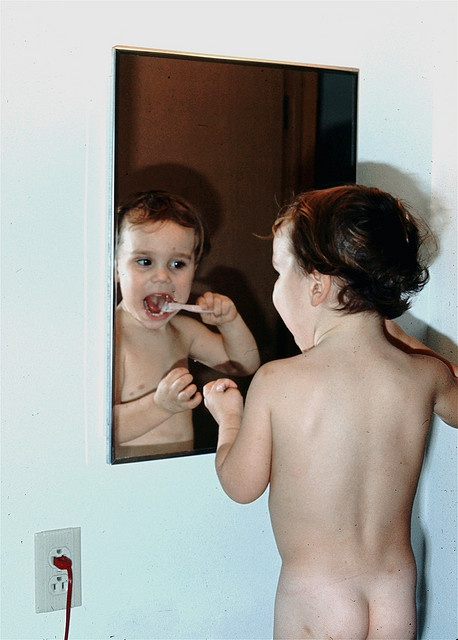Describe the objects in this image and their specific colors. I can see people in white, darkgray, tan, black, and gray tones, people in white, gray, tan, and black tones, and toothbrush in white, darkgray, and gray tones in this image. 